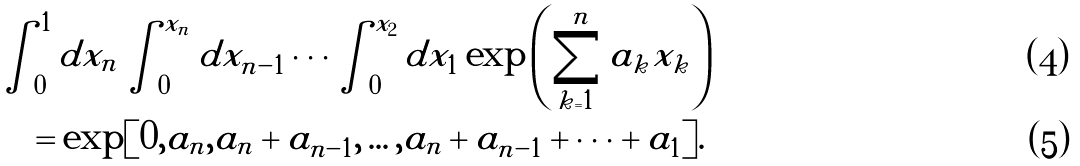Convert formula to latex. <formula><loc_0><loc_0><loc_500><loc_500>& \int _ { 0 } ^ { 1 } d x _ { n } \int _ { 0 } ^ { x _ { n } } d x _ { n - 1 } \cdots \int _ { 0 } ^ { x _ { 2 } } d x _ { 1 } \exp \left ( \sum _ { k = 1 } ^ { n } a _ { k } x _ { k } \right ) \\ & \quad = \exp [ 0 , a _ { n } , a _ { n } + a _ { n - 1 } , \dots , a _ { n } + a _ { n - 1 } + \cdots + a _ { 1 } ] .</formula> 